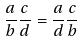Convert formula to latex. <formula><loc_0><loc_0><loc_500><loc_500>\frac { a } { b } \frac { c } { d } = \frac { a } { d } \frac { c } { b }</formula> 